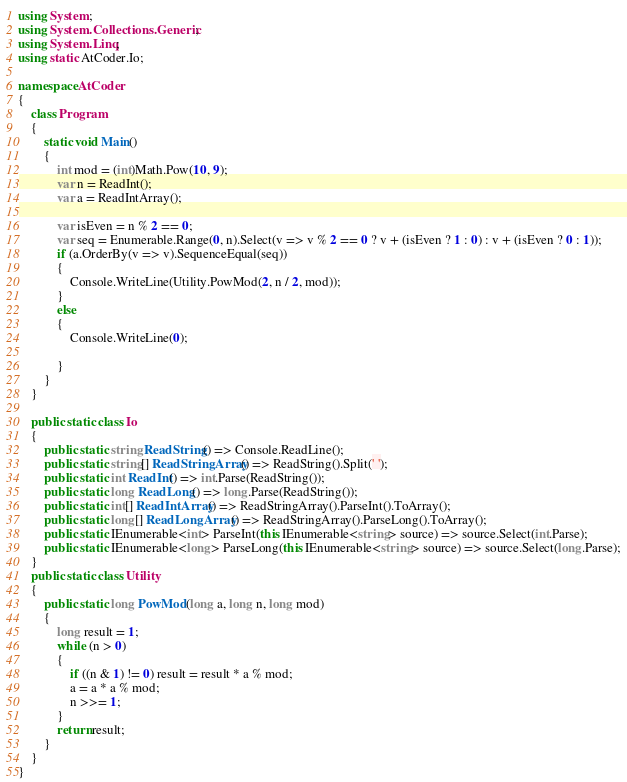Convert code to text. <code><loc_0><loc_0><loc_500><loc_500><_C#_>using System;
using System.Collections.Generic;
using System.Linq;
using static AtCoder.Io;

namespace AtCoder
{
    class Program
    {
        static void Main()
        {
            int mod = (int)Math.Pow(10, 9);
            var n = ReadInt();
            var a = ReadIntArray();

            var isEven = n % 2 == 0;
            var seq = Enumerable.Range(0, n).Select(v => v % 2 == 0 ? v + (isEven ? 1 : 0) : v + (isEven ? 0 : 1));
            if (a.OrderBy(v => v).SequenceEqual(seq))
            {
                Console.WriteLine(Utility.PowMod(2, n / 2, mod));
            }
            else
            {
                Console.WriteLine(0);

            }
        }
    }

    public static class Io
    {
        public static string ReadString() => Console.ReadLine();
        public static string[] ReadStringArray() => ReadString().Split(' ');
        public static int ReadInt() => int.Parse(ReadString());
        public static long ReadLong() => long.Parse(ReadString());
        public static int[] ReadIntArray() => ReadStringArray().ParseInt().ToArray();
        public static long[] ReadLongArray() => ReadStringArray().ParseLong().ToArray();
        public static IEnumerable<int> ParseInt(this IEnumerable<string> source) => source.Select(int.Parse);
        public static IEnumerable<long> ParseLong(this IEnumerable<string> source) => source.Select(long.Parse);
    }
    public static class Utility
    {
        public static long PowMod(long a, long n, long mod)
        {
            long result = 1;
            while (n > 0)
            {
                if ((n & 1) != 0) result = result * a % mod;
                a = a * a % mod;
                n >>= 1;
            }
            return result;
        }
    }
}
</code> 